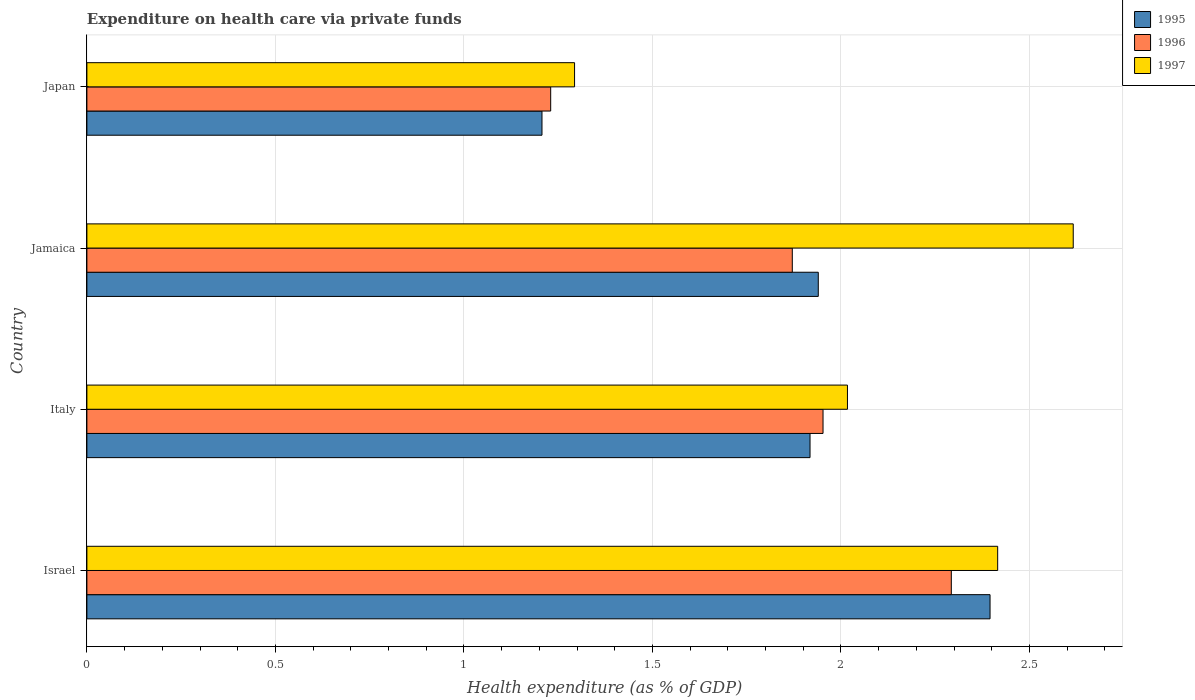How many groups of bars are there?
Keep it short and to the point. 4. Are the number of bars on each tick of the Y-axis equal?
Provide a short and direct response. Yes. How many bars are there on the 4th tick from the top?
Your response must be concise. 3. What is the label of the 2nd group of bars from the top?
Offer a terse response. Jamaica. In how many cases, is the number of bars for a given country not equal to the number of legend labels?
Make the answer very short. 0. What is the expenditure made on health care in 1996 in Italy?
Provide a short and direct response. 1.95. Across all countries, what is the maximum expenditure made on health care in 1996?
Offer a very short reply. 2.29. Across all countries, what is the minimum expenditure made on health care in 1997?
Keep it short and to the point. 1.29. What is the total expenditure made on health care in 1995 in the graph?
Make the answer very short. 7.46. What is the difference between the expenditure made on health care in 1996 in Israel and that in Japan?
Your answer should be compact. 1.06. What is the difference between the expenditure made on health care in 1996 in Israel and the expenditure made on health care in 1997 in Jamaica?
Provide a short and direct response. -0.32. What is the average expenditure made on health care in 1995 per country?
Provide a short and direct response. 1.87. What is the difference between the expenditure made on health care in 1996 and expenditure made on health care in 1995 in Jamaica?
Give a very brief answer. -0.07. What is the ratio of the expenditure made on health care in 1996 in Jamaica to that in Japan?
Provide a short and direct response. 1.52. Is the expenditure made on health care in 1997 in Israel less than that in Japan?
Offer a terse response. No. What is the difference between the highest and the second highest expenditure made on health care in 1995?
Your response must be concise. 0.46. What is the difference between the highest and the lowest expenditure made on health care in 1995?
Ensure brevity in your answer.  1.19. Is the sum of the expenditure made on health care in 1996 in Israel and Japan greater than the maximum expenditure made on health care in 1995 across all countries?
Give a very brief answer. Yes. How many bars are there?
Provide a succinct answer. 12. Are all the bars in the graph horizontal?
Give a very brief answer. Yes. What is the difference between two consecutive major ticks on the X-axis?
Your response must be concise. 0.5. Does the graph contain any zero values?
Your answer should be compact. No. Does the graph contain grids?
Offer a terse response. Yes. How many legend labels are there?
Make the answer very short. 3. How are the legend labels stacked?
Provide a succinct answer. Vertical. What is the title of the graph?
Your answer should be compact. Expenditure on health care via private funds. Does "1999" appear as one of the legend labels in the graph?
Your answer should be compact. No. What is the label or title of the X-axis?
Offer a very short reply. Health expenditure (as % of GDP). What is the label or title of the Y-axis?
Offer a very short reply. Country. What is the Health expenditure (as % of GDP) of 1995 in Israel?
Your answer should be very brief. 2.4. What is the Health expenditure (as % of GDP) of 1996 in Israel?
Give a very brief answer. 2.29. What is the Health expenditure (as % of GDP) in 1997 in Israel?
Provide a succinct answer. 2.42. What is the Health expenditure (as % of GDP) in 1995 in Italy?
Your response must be concise. 1.92. What is the Health expenditure (as % of GDP) of 1996 in Italy?
Keep it short and to the point. 1.95. What is the Health expenditure (as % of GDP) of 1997 in Italy?
Make the answer very short. 2.02. What is the Health expenditure (as % of GDP) in 1995 in Jamaica?
Make the answer very short. 1.94. What is the Health expenditure (as % of GDP) in 1996 in Jamaica?
Give a very brief answer. 1.87. What is the Health expenditure (as % of GDP) of 1997 in Jamaica?
Make the answer very short. 2.62. What is the Health expenditure (as % of GDP) of 1995 in Japan?
Provide a short and direct response. 1.21. What is the Health expenditure (as % of GDP) in 1996 in Japan?
Offer a terse response. 1.23. What is the Health expenditure (as % of GDP) of 1997 in Japan?
Your answer should be compact. 1.29. Across all countries, what is the maximum Health expenditure (as % of GDP) of 1995?
Give a very brief answer. 2.4. Across all countries, what is the maximum Health expenditure (as % of GDP) in 1996?
Your answer should be very brief. 2.29. Across all countries, what is the maximum Health expenditure (as % of GDP) of 1997?
Keep it short and to the point. 2.62. Across all countries, what is the minimum Health expenditure (as % of GDP) of 1995?
Ensure brevity in your answer.  1.21. Across all countries, what is the minimum Health expenditure (as % of GDP) in 1996?
Provide a succinct answer. 1.23. Across all countries, what is the minimum Health expenditure (as % of GDP) in 1997?
Your answer should be compact. 1.29. What is the total Health expenditure (as % of GDP) in 1995 in the graph?
Provide a succinct answer. 7.46. What is the total Health expenditure (as % of GDP) of 1996 in the graph?
Give a very brief answer. 7.35. What is the total Health expenditure (as % of GDP) of 1997 in the graph?
Keep it short and to the point. 8.34. What is the difference between the Health expenditure (as % of GDP) of 1995 in Israel and that in Italy?
Provide a succinct answer. 0.48. What is the difference between the Health expenditure (as % of GDP) in 1996 in Israel and that in Italy?
Give a very brief answer. 0.34. What is the difference between the Health expenditure (as % of GDP) of 1997 in Israel and that in Italy?
Offer a very short reply. 0.4. What is the difference between the Health expenditure (as % of GDP) of 1995 in Israel and that in Jamaica?
Ensure brevity in your answer.  0.46. What is the difference between the Health expenditure (as % of GDP) of 1996 in Israel and that in Jamaica?
Make the answer very short. 0.42. What is the difference between the Health expenditure (as % of GDP) in 1997 in Israel and that in Jamaica?
Keep it short and to the point. -0.2. What is the difference between the Health expenditure (as % of GDP) of 1995 in Israel and that in Japan?
Offer a terse response. 1.19. What is the difference between the Health expenditure (as % of GDP) in 1996 in Israel and that in Japan?
Offer a terse response. 1.06. What is the difference between the Health expenditure (as % of GDP) of 1997 in Israel and that in Japan?
Your answer should be very brief. 1.12. What is the difference between the Health expenditure (as % of GDP) of 1995 in Italy and that in Jamaica?
Keep it short and to the point. -0.02. What is the difference between the Health expenditure (as % of GDP) in 1996 in Italy and that in Jamaica?
Your answer should be compact. 0.08. What is the difference between the Health expenditure (as % of GDP) of 1997 in Italy and that in Jamaica?
Offer a terse response. -0.6. What is the difference between the Health expenditure (as % of GDP) of 1995 in Italy and that in Japan?
Provide a short and direct response. 0.71. What is the difference between the Health expenditure (as % of GDP) of 1996 in Italy and that in Japan?
Keep it short and to the point. 0.72. What is the difference between the Health expenditure (as % of GDP) in 1997 in Italy and that in Japan?
Ensure brevity in your answer.  0.72. What is the difference between the Health expenditure (as % of GDP) of 1995 in Jamaica and that in Japan?
Keep it short and to the point. 0.73. What is the difference between the Health expenditure (as % of GDP) of 1996 in Jamaica and that in Japan?
Give a very brief answer. 0.64. What is the difference between the Health expenditure (as % of GDP) of 1997 in Jamaica and that in Japan?
Make the answer very short. 1.32. What is the difference between the Health expenditure (as % of GDP) of 1995 in Israel and the Health expenditure (as % of GDP) of 1996 in Italy?
Your response must be concise. 0.44. What is the difference between the Health expenditure (as % of GDP) of 1995 in Israel and the Health expenditure (as % of GDP) of 1997 in Italy?
Give a very brief answer. 0.38. What is the difference between the Health expenditure (as % of GDP) of 1996 in Israel and the Health expenditure (as % of GDP) of 1997 in Italy?
Make the answer very short. 0.28. What is the difference between the Health expenditure (as % of GDP) of 1995 in Israel and the Health expenditure (as % of GDP) of 1996 in Jamaica?
Your response must be concise. 0.52. What is the difference between the Health expenditure (as % of GDP) of 1995 in Israel and the Health expenditure (as % of GDP) of 1997 in Jamaica?
Provide a short and direct response. -0.22. What is the difference between the Health expenditure (as % of GDP) in 1996 in Israel and the Health expenditure (as % of GDP) in 1997 in Jamaica?
Offer a terse response. -0.32. What is the difference between the Health expenditure (as % of GDP) of 1995 in Israel and the Health expenditure (as % of GDP) of 1996 in Japan?
Give a very brief answer. 1.17. What is the difference between the Health expenditure (as % of GDP) in 1995 in Israel and the Health expenditure (as % of GDP) in 1997 in Japan?
Ensure brevity in your answer.  1.1. What is the difference between the Health expenditure (as % of GDP) of 1996 in Israel and the Health expenditure (as % of GDP) of 1997 in Japan?
Keep it short and to the point. 1. What is the difference between the Health expenditure (as % of GDP) of 1995 in Italy and the Health expenditure (as % of GDP) of 1996 in Jamaica?
Keep it short and to the point. 0.05. What is the difference between the Health expenditure (as % of GDP) in 1995 in Italy and the Health expenditure (as % of GDP) in 1997 in Jamaica?
Provide a succinct answer. -0.7. What is the difference between the Health expenditure (as % of GDP) in 1996 in Italy and the Health expenditure (as % of GDP) in 1997 in Jamaica?
Offer a very short reply. -0.66. What is the difference between the Health expenditure (as % of GDP) in 1995 in Italy and the Health expenditure (as % of GDP) in 1996 in Japan?
Provide a succinct answer. 0.69. What is the difference between the Health expenditure (as % of GDP) of 1995 in Italy and the Health expenditure (as % of GDP) of 1997 in Japan?
Ensure brevity in your answer.  0.62. What is the difference between the Health expenditure (as % of GDP) of 1996 in Italy and the Health expenditure (as % of GDP) of 1997 in Japan?
Your response must be concise. 0.66. What is the difference between the Health expenditure (as % of GDP) of 1995 in Jamaica and the Health expenditure (as % of GDP) of 1996 in Japan?
Provide a succinct answer. 0.71. What is the difference between the Health expenditure (as % of GDP) in 1995 in Jamaica and the Health expenditure (as % of GDP) in 1997 in Japan?
Your response must be concise. 0.65. What is the difference between the Health expenditure (as % of GDP) of 1996 in Jamaica and the Health expenditure (as % of GDP) of 1997 in Japan?
Provide a succinct answer. 0.58. What is the average Health expenditure (as % of GDP) in 1995 per country?
Ensure brevity in your answer.  1.86. What is the average Health expenditure (as % of GDP) in 1996 per country?
Your answer should be compact. 1.84. What is the average Health expenditure (as % of GDP) in 1997 per country?
Ensure brevity in your answer.  2.09. What is the difference between the Health expenditure (as % of GDP) of 1995 and Health expenditure (as % of GDP) of 1996 in Israel?
Offer a terse response. 0.1. What is the difference between the Health expenditure (as % of GDP) of 1995 and Health expenditure (as % of GDP) of 1997 in Israel?
Make the answer very short. -0.02. What is the difference between the Health expenditure (as % of GDP) in 1996 and Health expenditure (as % of GDP) in 1997 in Israel?
Give a very brief answer. -0.12. What is the difference between the Health expenditure (as % of GDP) in 1995 and Health expenditure (as % of GDP) in 1996 in Italy?
Keep it short and to the point. -0.03. What is the difference between the Health expenditure (as % of GDP) of 1995 and Health expenditure (as % of GDP) of 1997 in Italy?
Make the answer very short. -0.1. What is the difference between the Health expenditure (as % of GDP) in 1996 and Health expenditure (as % of GDP) in 1997 in Italy?
Make the answer very short. -0.06. What is the difference between the Health expenditure (as % of GDP) in 1995 and Health expenditure (as % of GDP) in 1996 in Jamaica?
Offer a very short reply. 0.07. What is the difference between the Health expenditure (as % of GDP) of 1995 and Health expenditure (as % of GDP) of 1997 in Jamaica?
Ensure brevity in your answer.  -0.68. What is the difference between the Health expenditure (as % of GDP) in 1996 and Health expenditure (as % of GDP) in 1997 in Jamaica?
Make the answer very short. -0.75. What is the difference between the Health expenditure (as % of GDP) of 1995 and Health expenditure (as % of GDP) of 1996 in Japan?
Make the answer very short. -0.02. What is the difference between the Health expenditure (as % of GDP) of 1995 and Health expenditure (as % of GDP) of 1997 in Japan?
Keep it short and to the point. -0.09. What is the difference between the Health expenditure (as % of GDP) in 1996 and Health expenditure (as % of GDP) in 1997 in Japan?
Ensure brevity in your answer.  -0.06. What is the ratio of the Health expenditure (as % of GDP) in 1995 in Israel to that in Italy?
Give a very brief answer. 1.25. What is the ratio of the Health expenditure (as % of GDP) of 1996 in Israel to that in Italy?
Provide a succinct answer. 1.17. What is the ratio of the Health expenditure (as % of GDP) in 1997 in Israel to that in Italy?
Your response must be concise. 1.2. What is the ratio of the Health expenditure (as % of GDP) in 1995 in Israel to that in Jamaica?
Your answer should be very brief. 1.23. What is the ratio of the Health expenditure (as % of GDP) of 1996 in Israel to that in Jamaica?
Make the answer very short. 1.23. What is the ratio of the Health expenditure (as % of GDP) of 1997 in Israel to that in Jamaica?
Ensure brevity in your answer.  0.92. What is the ratio of the Health expenditure (as % of GDP) in 1995 in Israel to that in Japan?
Provide a short and direct response. 1.98. What is the ratio of the Health expenditure (as % of GDP) of 1996 in Israel to that in Japan?
Ensure brevity in your answer.  1.86. What is the ratio of the Health expenditure (as % of GDP) of 1997 in Israel to that in Japan?
Offer a very short reply. 1.87. What is the ratio of the Health expenditure (as % of GDP) in 1995 in Italy to that in Jamaica?
Make the answer very short. 0.99. What is the ratio of the Health expenditure (as % of GDP) in 1996 in Italy to that in Jamaica?
Your answer should be compact. 1.04. What is the ratio of the Health expenditure (as % of GDP) in 1997 in Italy to that in Jamaica?
Your response must be concise. 0.77. What is the ratio of the Health expenditure (as % of GDP) of 1995 in Italy to that in Japan?
Give a very brief answer. 1.59. What is the ratio of the Health expenditure (as % of GDP) in 1996 in Italy to that in Japan?
Ensure brevity in your answer.  1.59. What is the ratio of the Health expenditure (as % of GDP) of 1997 in Italy to that in Japan?
Your answer should be very brief. 1.56. What is the ratio of the Health expenditure (as % of GDP) of 1995 in Jamaica to that in Japan?
Provide a short and direct response. 1.61. What is the ratio of the Health expenditure (as % of GDP) of 1996 in Jamaica to that in Japan?
Give a very brief answer. 1.52. What is the ratio of the Health expenditure (as % of GDP) in 1997 in Jamaica to that in Japan?
Give a very brief answer. 2.02. What is the difference between the highest and the second highest Health expenditure (as % of GDP) of 1995?
Make the answer very short. 0.46. What is the difference between the highest and the second highest Health expenditure (as % of GDP) in 1996?
Offer a very short reply. 0.34. What is the difference between the highest and the second highest Health expenditure (as % of GDP) of 1997?
Your answer should be very brief. 0.2. What is the difference between the highest and the lowest Health expenditure (as % of GDP) in 1995?
Offer a terse response. 1.19. What is the difference between the highest and the lowest Health expenditure (as % of GDP) of 1996?
Make the answer very short. 1.06. What is the difference between the highest and the lowest Health expenditure (as % of GDP) in 1997?
Offer a terse response. 1.32. 